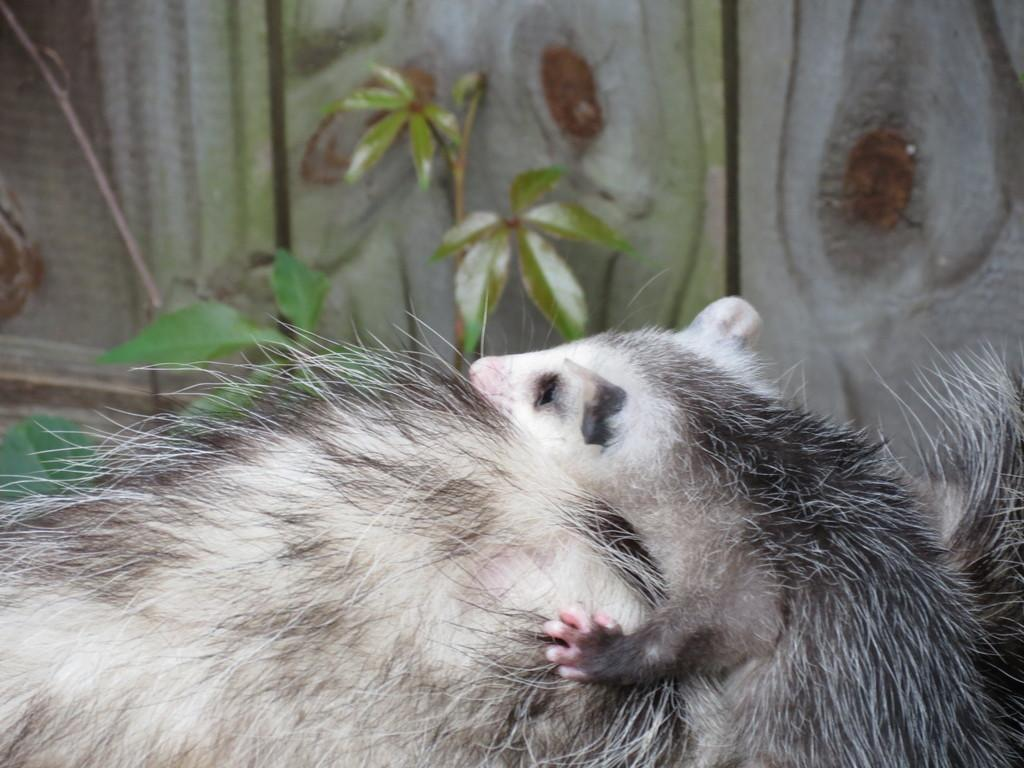What type of living organism can be seen in the image? There is an animal in the image. What else can be seen in the image besides the animal? There are plants in the image. How many potatoes are visible in the image? There are no potatoes present in the image. How many brothers does the animal in the image have? The image does not provide information about the animal's family, so it is impossible to determine the number of brothers the animal has. 